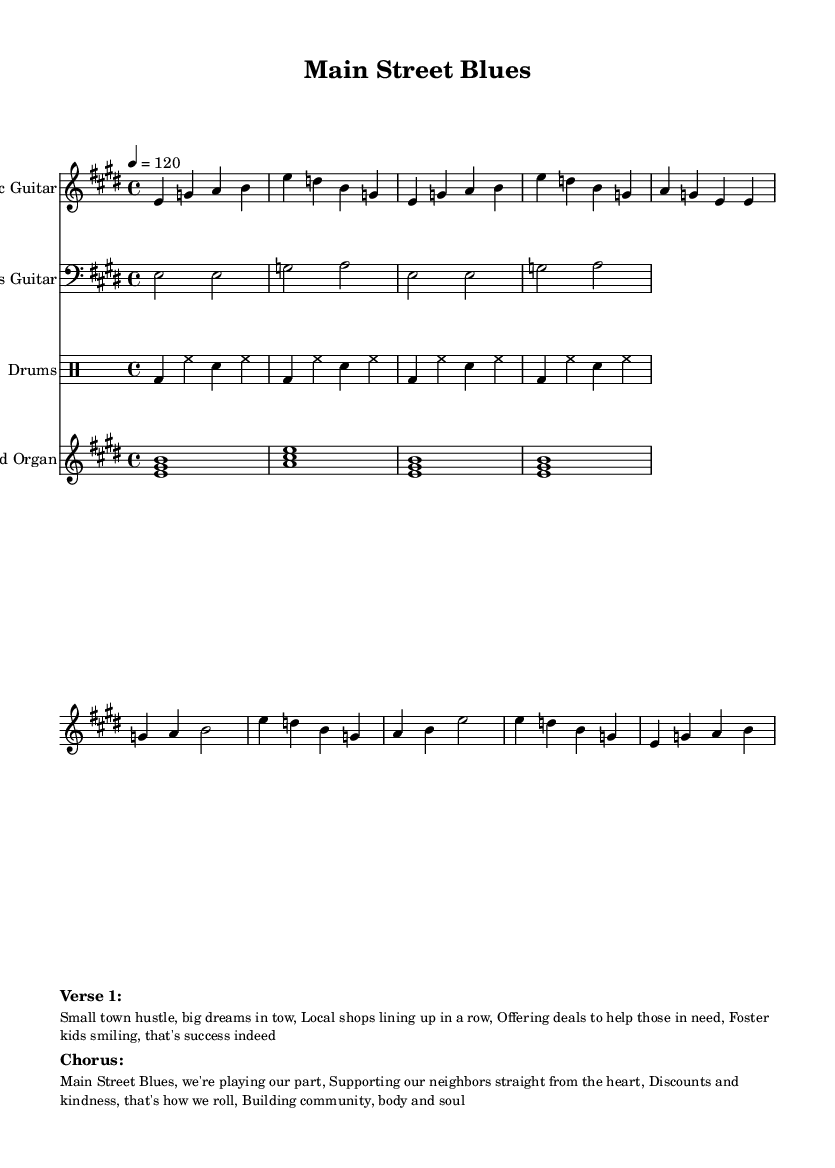What is the key signature of this music? The key signature is E major, which has four sharps (F#, C#, G#, D#). You can identify this from the clef at the beginning of the piece where the key signature symbols appear.
Answer: E major What is the time signature of this piece? The time signature of this music is 4/4. This means there are four beats in each measure and a quarter note receives one beat. This can be seen at the beginning of the music where the time signature is indicated.
Answer: 4/4 What tempo is indicated for this piece? The tempo is indicated as 120 beats per minute (tempo marking of 4 = 120). This information is shown in the tempo markings towards the beginning of the sheet music.
Answer: 120 Which instrument plays the melody? The instrument playing the melody is the Electric Guitar. This is evident as the first staff is labeled "Electric Guitar" and contains the main melodic line.
Answer: Electric Guitar How many measures are there in the piece? There are 16 measures in this piece. By counting the vertical lines separating the measures in the sheet music, you can determine the total number of measures.
Answer: 16 What is the theme of the lyrics in the song? The theme of the lyrics focuses on community support and small-town entrepreneurship, exemplified through phrases about local shops and helping foster children. By examining the lyrics presented in the markup section, the overall theme becomes clear.
Answer: Community support What style of music is this piece? This piece is categorized as Electric Blues, which is evident by the stylistic elements such as the instrumentation (like Electric Guitar and Hammond Organ) and the lyrical themes found in blues music culture.
Answer: Electric Blues 